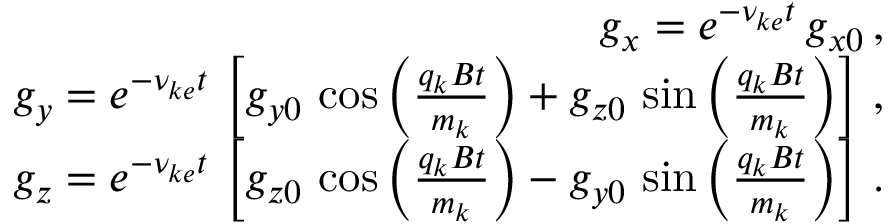Convert formula to latex. <formula><loc_0><loc_0><loc_500><loc_500>\begin{array} { r l r } & { g _ { x } = e ^ { - \nu _ { k e } t } \, g _ { x 0 } \, , } \\ & { g _ { y } = e ^ { - \nu _ { k e } t } \, \left [ g _ { y 0 } \, \cos \left ( \frac { q _ { k } B t } { m _ { k } } \right ) + g _ { z 0 } \, \sin \left ( \frac { q _ { k } B t } { m _ { k } } \right ) \right ] \, , } \\ & { g _ { z } = e ^ { - \nu _ { k e } t } \, \left [ g _ { z 0 } \, \cos \left ( \frac { q _ { k } B t } { m _ { k } } \right ) - g _ { y 0 } \, \sin \left ( \frac { q _ { k } B t } { m _ { k } } \right ) \right ] \, . } \end{array}</formula> 